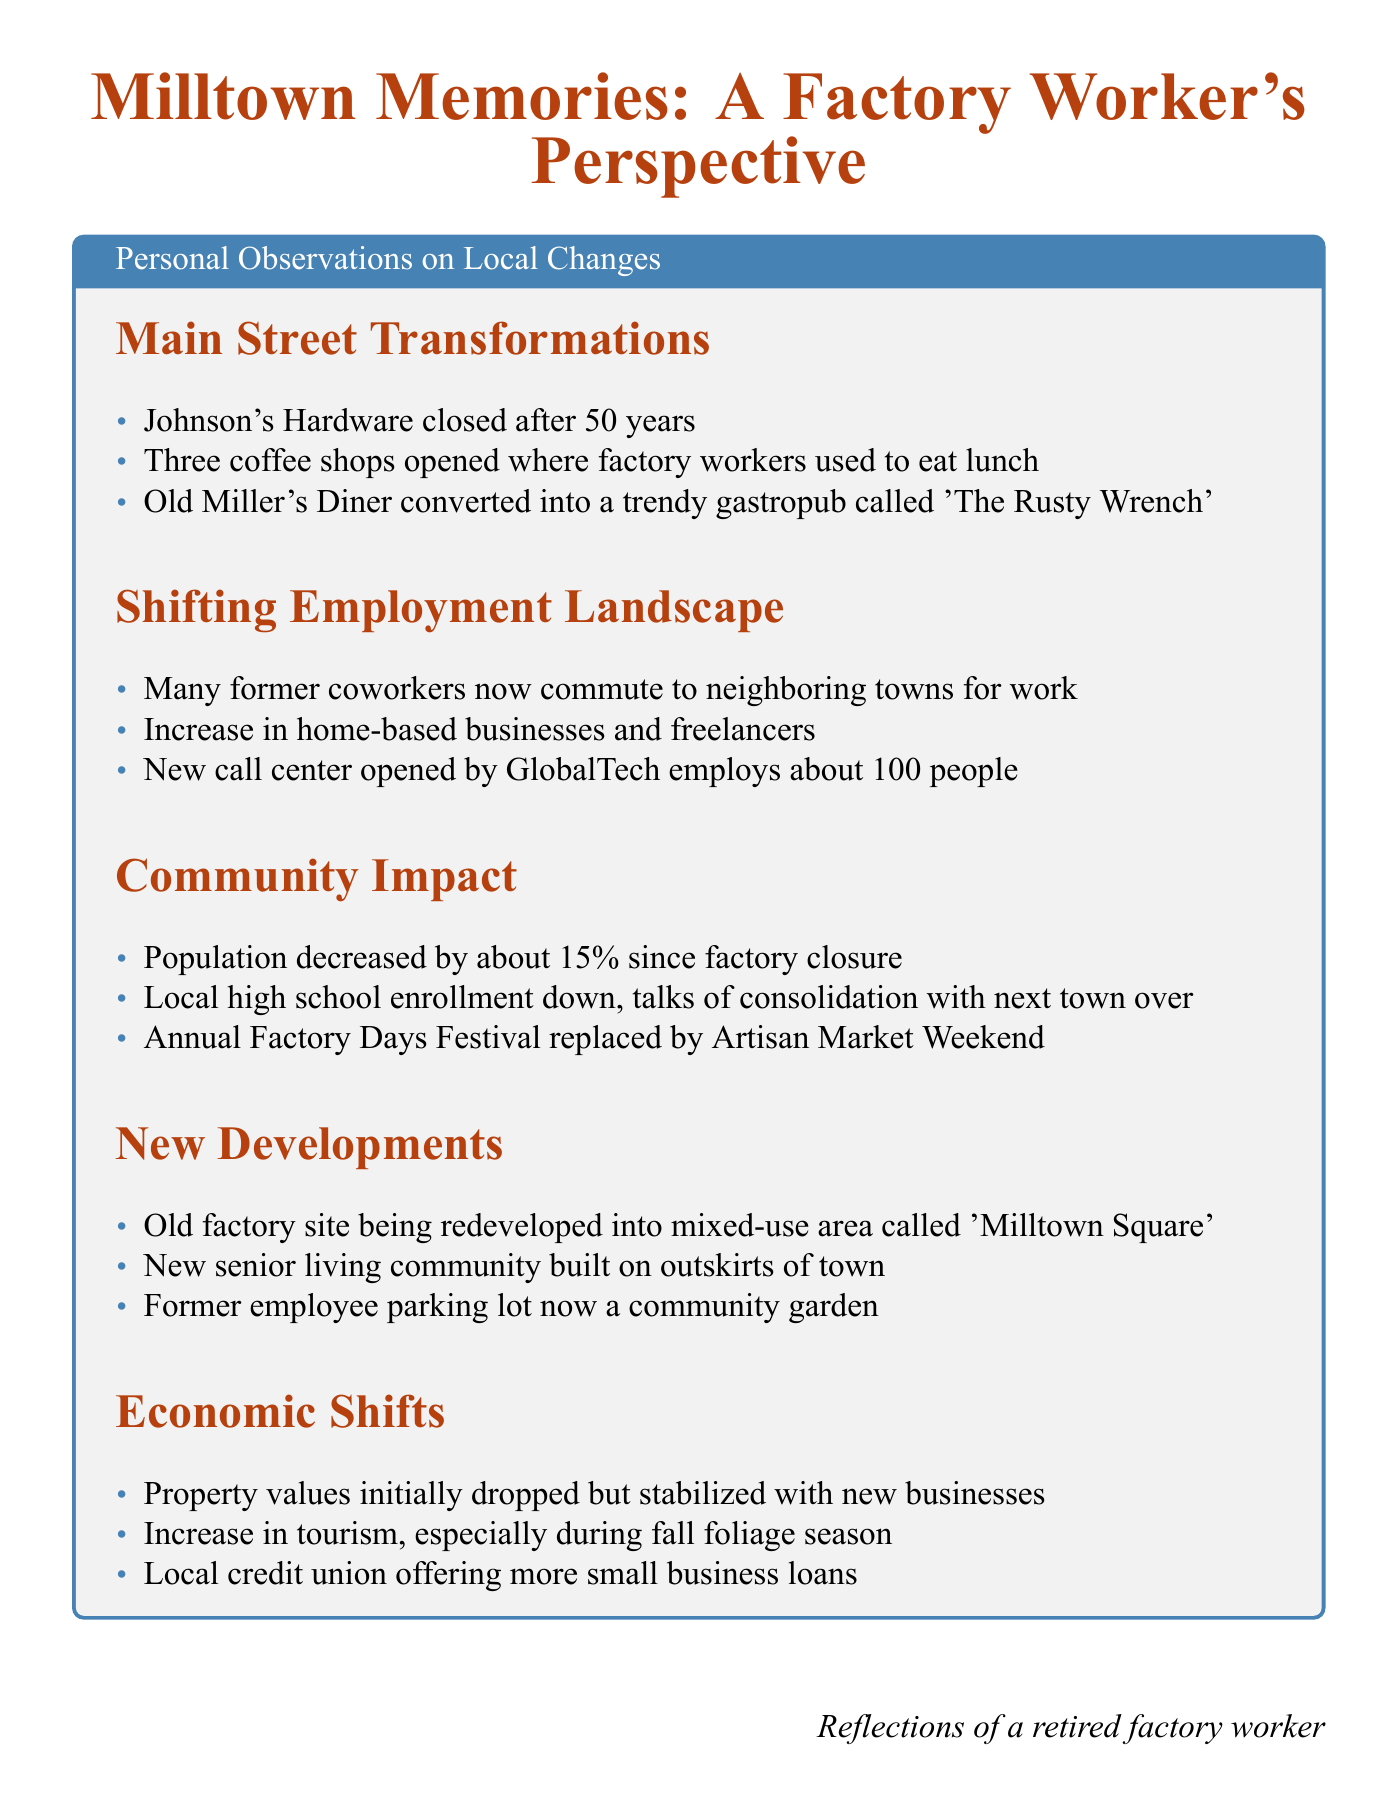What business closed after 50 years? Johnson's Hardware is mentioned as having closed after 50 years in the document.
Answer: Johnson's Hardware How much did the population decrease since the factory closure? The document states that the population decreased by about 15% since the factory closure.
Answer: 15% What is the new name of Old Miller's Diner? The document states that Old Miller's Diner was converted into a gastropub called 'The Rusty Wrench'.
Answer: The Rusty Wrench What type of area is the old factory site being redeveloped into? It is mentioned that the old factory site is being redeveloped into a mixed-use area called 'Milltown Square'.
Answer: mixed-use area What impact did the factory's closure have on local high school enrollment? The document states that local high school enrollment is down, with talks of consolidation with the next town over due to this decrease.
Answer: down How many people does the new call center employ? The document mentions that the new call center opened by GlobalTech employs about 100 people.
Answer: about 100 people 